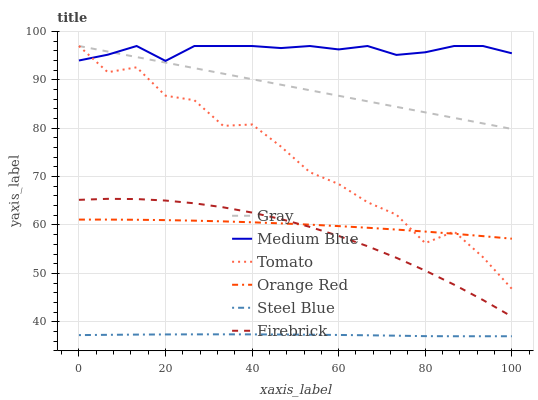Does Steel Blue have the minimum area under the curve?
Answer yes or no. Yes. Does Medium Blue have the maximum area under the curve?
Answer yes or no. Yes. Does Gray have the minimum area under the curve?
Answer yes or no. No. Does Gray have the maximum area under the curve?
Answer yes or no. No. Is Gray the smoothest?
Answer yes or no. Yes. Is Tomato the roughest?
Answer yes or no. Yes. Is Firebrick the smoothest?
Answer yes or no. No. Is Firebrick the roughest?
Answer yes or no. No. Does Steel Blue have the lowest value?
Answer yes or no. Yes. Does Gray have the lowest value?
Answer yes or no. No. Does Medium Blue have the highest value?
Answer yes or no. Yes. Does Firebrick have the highest value?
Answer yes or no. No. Is Steel Blue less than Gray?
Answer yes or no. Yes. Is Tomato greater than Steel Blue?
Answer yes or no. Yes. Does Tomato intersect Orange Red?
Answer yes or no. Yes. Is Tomato less than Orange Red?
Answer yes or no. No. Is Tomato greater than Orange Red?
Answer yes or no. No. Does Steel Blue intersect Gray?
Answer yes or no. No. 